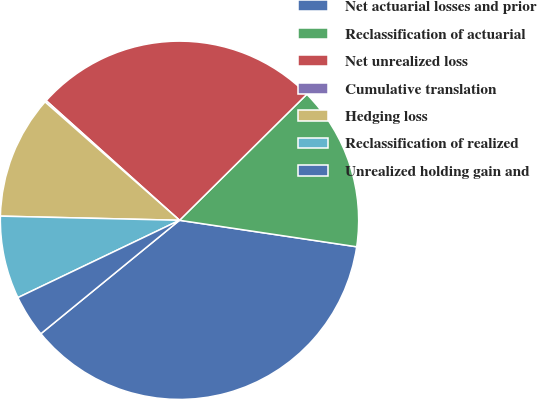<chart> <loc_0><loc_0><loc_500><loc_500><pie_chart><fcel>Net actuarial losses and prior<fcel>Reclassification of actuarial<fcel>Net unrealized loss<fcel>Cumulative translation<fcel>Hedging loss<fcel>Reclassification of realized<fcel>Unrealized holding gain and<nl><fcel>36.72%<fcel>14.78%<fcel>25.94%<fcel>0.15%<fcel>11.12%<fcel>7.47%<fcel>3.81%<nl></chart> 